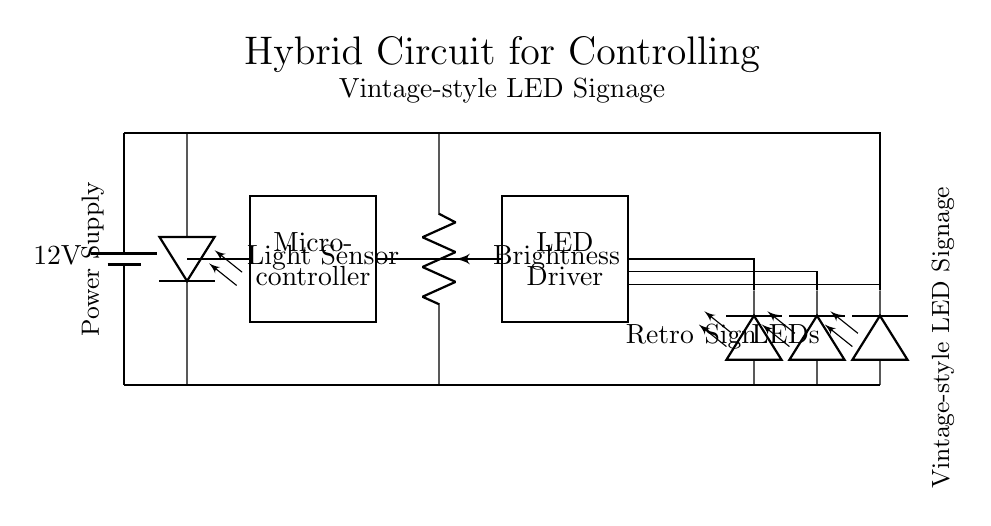What is the power supply voltage in this circuit? The circuit shows a battery component labeled with a voltage of 12V at the top left corner. This indicates the power source voltage.
Answer: 12V What component is used for brightness control? The diagram includes a potentiometer labeled "Brightness," which indicates its function to adjust LED brightness through variable resistance.
Answer: Potentiometer How many LEDs are connected in this circuit? The circuit has three LED components labeled "Retro," "Sign," and "LEDs" positioned at the bottom right. This indicates that the total count of LED components is three.
Answer: Three What type of sensor is used in the circuit? The circuit diagram depicts a component labeled "Light Sensor," indicating that a photodiode is used for sensing ambient light conditions.
Answer: Photodiode How does the microcontroller interact with the LED Driver? The microcontroller is connected to the LED driver with a direct line, meaning that it sends signals to the LED driver to control the operation of the connected LEDs.
Answer: Direct connection What is the purpose of the ambient light sensor in this circuit? The ambient light sensor detects surrounding light levels, influencing the microcontroller to adjust the LED brightness accordingly, optimizing visibility and energy use.
Answer: Adjust LED brightness What type of circuit is this? The circuit combines both analog (potentiometer, photodiode) and digital (microcontroller) components, classifying it as a hybrid circuit.
Answer: Hybrid circuit 